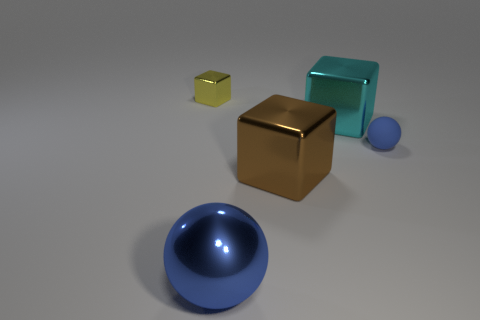Add 1 small blue objects. How many objects exist? 6 Subtract all cubes. How many objects are left? 2 Add 5 blue metal spheres. How many blue metal spheres are left? 6 Add 1 large brown things. How many large brown things exist? 2 Subtract 1 brown cubes. How many objects are left? 4 Subtract all cyan spheres. Subtract all yellow metallic things. How many objects are left? 4 